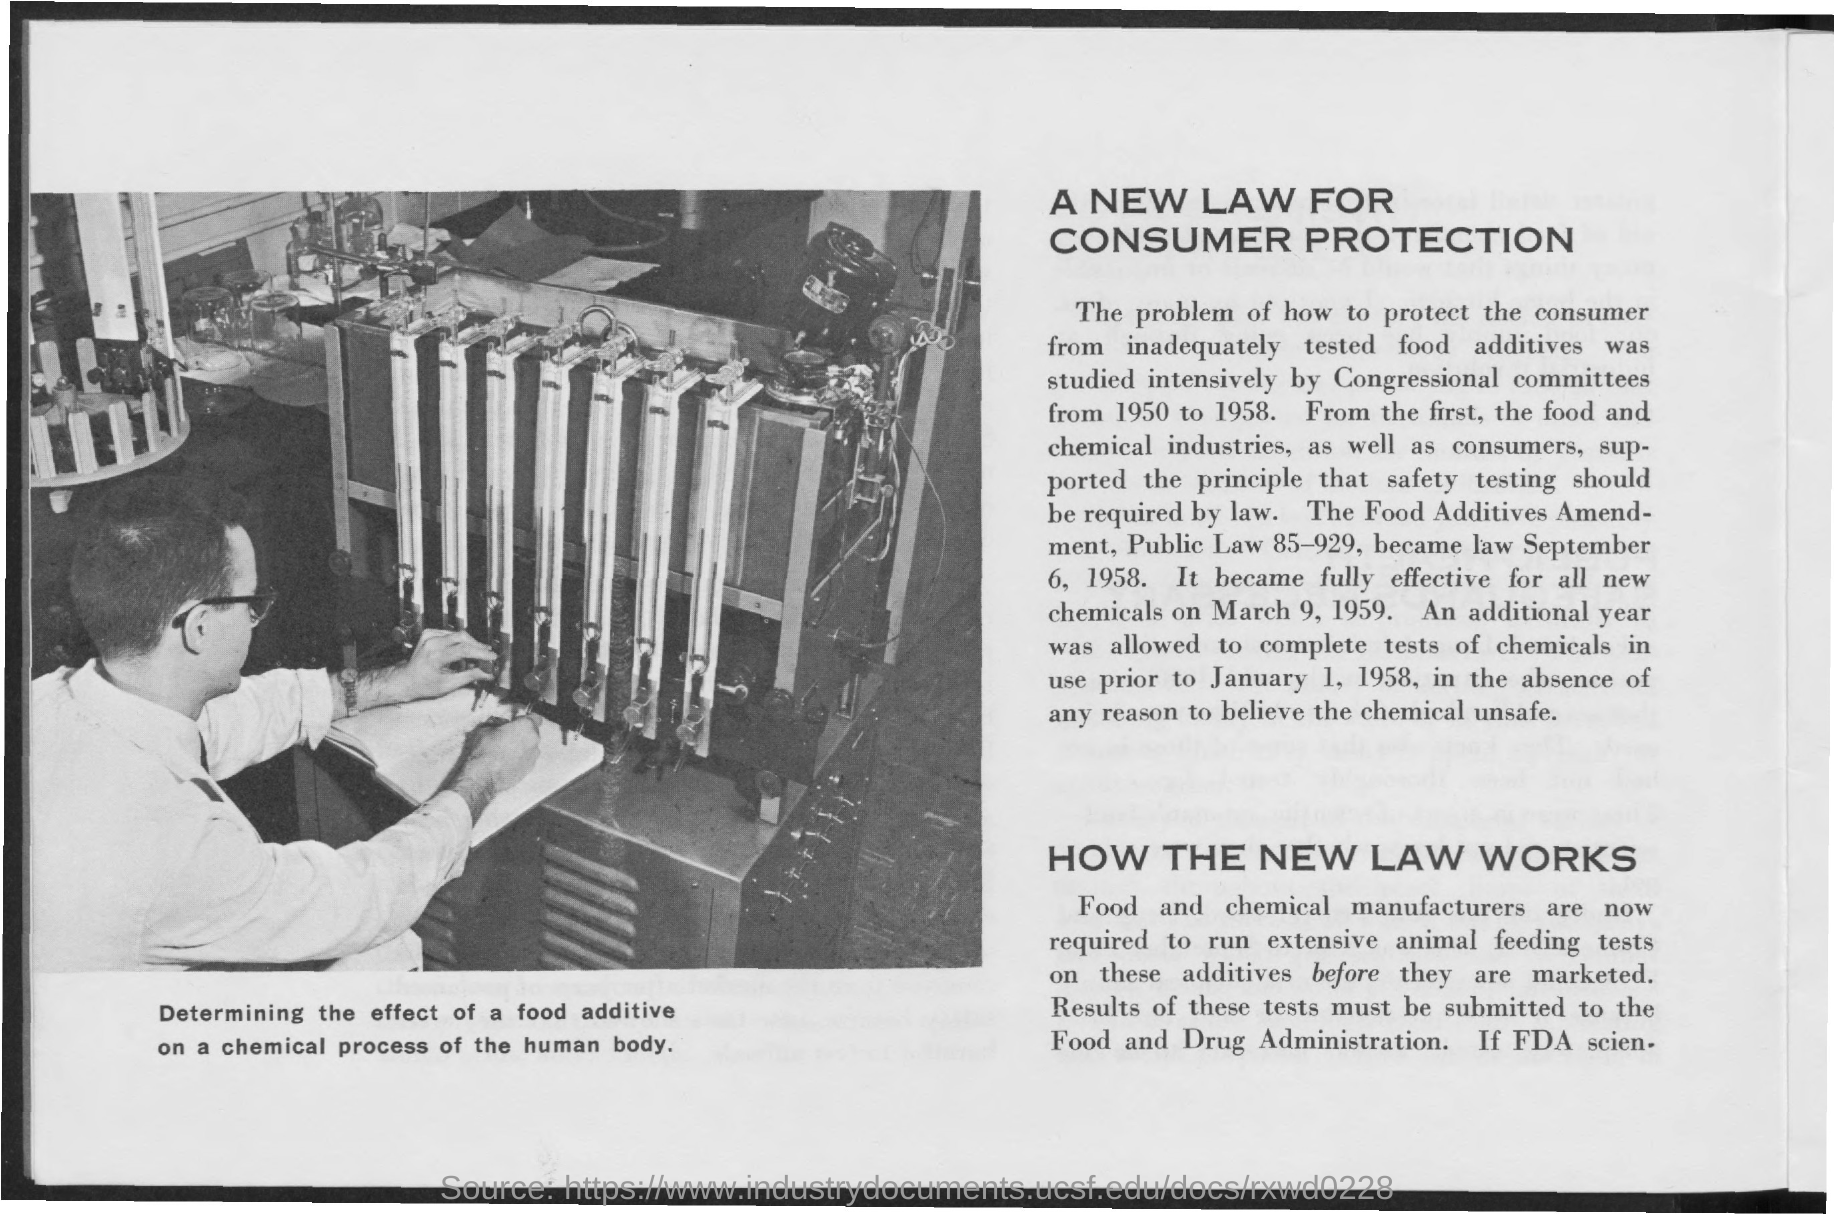What is the first title in the document?
Provide a succinct answer. A new law for Consumer Protection. What is the second title in the document?
Keep it short and to the point. How the new law works. 